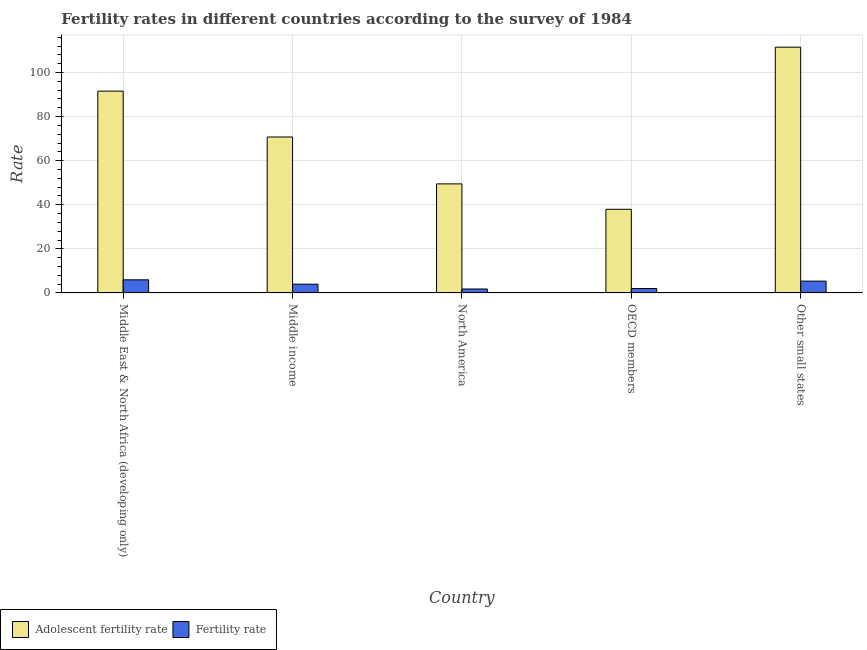How many groups of bars are there?
Make the answer very short. 5. How many bars are there on the 3rd tick from the left?
Provide a succinct answer. 2. How many bars are there on the 2nd tick from the right?
Your response must be concise. 2. What is the label of the 1st group of bars from the left?
Your answer should be very brief. Middle East & North Africa (developing only). What is the fertility rate in Middle income?
Keep it short and to the point. 3.97. Across all countries, what is the maximum fertility rate?
Provide a succinct answer. 5.95. Across all countries, what is the minimum adolescent fertility rate?
Offer a very short reply. 37.95. In which country was the fertility rate maximum?
Ensure brevity in your answer.  Middle East & North Africa (developing only). In which country was the fertility rate minimum?
Offer a very short reply. North America. What is the total fertility rate in the graph?
Your response must be concise. 19.09. What is the difference between the adolescent fertility rate in Middle income and that in Other small states?
Your answer should be very brief. -40.75. What is the difference between the adolescent fertility rate in Middle income and the fertility rate in Middle East & North Africa (developing only)?
Your response must be concise. 64.79. What is the average fertility rate per country?
Offer a very short reply. 3.82. What is the difference between the adolescent fertility rate and fertility rate in OECD members?
Keep it short and to the point. 35.93. In how many countries, is the adolescent fertility rate greater than 88 ?
Your answer should be very brief. 2. What is the ratio of the fertility rate in Middle East & North Africa (developing only) to that in OECD members?
Your answer should be compact. 2.95. Is the fertility rate in Middle East & North Africa (developing only) less than that in Middle income?
Give a very brief answer. No. Is the difference between the fertility rate in Middle income and Other small states greater than the difference between the adolescent fertility rate in Middle income and Other small states?
Provide a short and direct response. Yes. What is the difference between the highest and the second highest adolescent fertility rate?
Make the answer very short. 19.95. What is the difference between the highest and the lowest adolescent fertility rate?
Keep it short and to the point. 73.55. In how many countries, is the adolescent fertility rate greater than the average adolescent fertility rate taken over all countries?
Offer a very short reply. 2. Is the sum of the fertility rate in Middle income and Other small states greater than the maximum adolescent fertility rate across all countries?
Offer a terse response. No. What does the 1st bar from the left in Middle East & North Africa (developing only) represents?
Your answer should be very brief. Adolescent fertility rate. What does the 2nd bar from the right in Other small states represents?
Offer a terse response. Adolescent fertility rate. How many bars are there?
Offer a terse response. 10. Are all the bars in the graph horizontal?
Your response must be concise. No. How many countries are there in the graph?
Offer a very short reply. 5. What is the difference between two consecutive major ticks on the Y-axis?
Offer a terse response. 20. Are the values on the major ticks of Y-axis written in scientific E-notation?
Offer a very short reply. No. Does the graph contain any zero values?
Give a very brief answer. No. Does the graph contain grids?
Provide a succinct answer. Yes. How many legend labels are there?
Make the answer very short. 2. How are the legend labels stacked?
Your answer should be compact. Horizontal. What is the title of the graph?
Your response must be concise. Fertility rates in different countries according to the survey of 1984. What is the label or title of the Y-axis?
Keep it short and to the point. Rate. What is the Rate of Adolescent fertility rate in Middle East & North Africa (developing only)?
Offer a terse response. 91.55. What is the Rate in Fertility rate in Middle East & North Africa (developing only)?
Offer a terse response. 5.95. What is the Rate of Adolescent fertility rate in Middle income?
Offer a very short reply. 70.74. What is the Rate in Fertility rate in Middle income?
Your answer should be very brief. 3.97. What is the Rate in Adolescent fertility rate in North America?
Give a very brief answer. 49.47. What is the Rate in Fertility rate in North America?
Give a very brief answer. 1.79. What is the Rate of Adolescent fertility rate in OECD members?
Your response must be concise. 37.95. What is the Rate of Fertility rate in OECD members?
Keep it short and to the point. 2.02. What is the Rate of Adolescent fertility rate in Other small states?
Provide a short and direct response. 111.5. What is the Rate of Fertility rate in Other small states?
Your answer should be compact. 5.36. Across all countries, what is the maximum Rate of Adolescent fertility rate?
Provide a short and direct response. 111.5. Across all countries, what is the maximum Rate of Fertility rate?
Your answer should be very brief. 5.95. Across all countries, what is the minimum Rate of Adolescent fertility rate?
Ensure brevity in your answer.  37.95. Across all countries, what is the minimum Rate of Fertility rate?
Your answer should be very brief. 1.79. What is the total Rate in Adolescent fertility rate in the graph?
Give a very brief answer. 361.21. What is the total Rate in Fertility rate in the graph?
Make the answer very short. 19.09. What is the difference between the Rate in Adolescent fertility rate in Middle East & North Africa (developing only) and that in Middle income?
Your response must be concise. 20.8. What is the difference between the Rate in Fertility rate in Middle East & North Africa (developing only) and that in Middle income?
Ensure brevity in your answer.  1.98. What is the difference between the Rate in Adolescent fertility rate in Middle East & North Africa (developing only) and that in North America?
Provide a succinct answer. 42.07. What is the difference between the Rate of Fertility rate in Middle East & North Africa (developing only) and that in North America?
Your answer should be compact. 4.16. What is the difference between the Rate of Adolescent fertility rate in Middle East & North Africa (developing only) and that in OECD members?
Give a very brief answer. 53.6. What is the difference between the Rate in Fertility rate in Middle East & North Africa (developing only) and that in OECD members?
Provide a short and direct response. 3.93. What is the difference between the Rate of Adolescent fertility rate in Middle East & North Africa (developing only) and that in Other small states?
Provide a short and direct response. -19.95. What is the difference between the Rate in Fertility rate in Middle East & North Africa (developing only) and that in Other small states?
Provide a succinct answer. 0.59. What is the difference between the Rate of Adolescent fertility rate in Middle income and that in North America?
Give a very brief answer. 21.27. What is the difference between the Rate of Fertility rate in Middle income and that in North America?
Make the answer very short. 2.18. What is the difference between the Rate in Adolescent fertility rate in Middle income and that in OECD members?
Give a very brief answer. 32.79. What is the difference between the Rate of Fertility rate in Middle income and that in OECD members?
Keep it short and to the point. 1.95. What is the difference between the Rate of Adolescent fertility rate in Middle income and that in Other small states?
Your answer should be very brief. -40.75. What is the difference between the Rate of Fertility rate in Middle income and that in Other small states?
Provide a succinct answer. -1.39. What is the difference between the Rate in Adolescent fertility rate in North America and that in OECD members?
Make the answer very short. 11.52. What is the difference between the Rate of Fertility rate in North America and that in OECD members?
Make the answer very short. -0.23. What is the difference between the Rate of Adolescent fertility rate in North America and that in Other small states?
Give a very brief answer. -62.02. What is the difference between the Rate of Fertility rate in North America and that in Other small states?
Your answer should be compact. -3.57. What is the difference between the Rate of Adolescent fertility rate in OECD members and that in Other small states?
Keep it short and to the point. -73.55. What is the difference between the Rate in Fertility rate in OECD members and that in Other small states?
Offer a terse response. -3.34. What is the difference between the Rate in Adolescent fertility rate in Middle East & North Africa (developing only) and the Rate in Fertility rate in Middle income?
Give a very brief answer. 87.57. What is the difference between the Rate in Adolescent fertility rate in Middle East & North Africa (developing only) and the Rate in Fertility rate in North America?
Provide a short and direct response. 89.76. What is the difference between the Rate of Adolescent fertility rate in Middle East & North Africa (developing only) and the Rate of Fertility rate in OECD members?
Make the answer very short. 89.53. What is the difference between the Rate of Adolescent fertility rate in Middle East & North Africa (developing only) and the Rate of Fertility rate in Other small states?
Your answer should be very brief. 86.19. What is the difference between the Rate of Adolescent fertility rate in Middle income and the Rate of Fertility rate in North America?
Give a very brief answer. 68.95. What is the difference between the Rate of Adolescent fertility rate in Middle income and the Rate of Fertility rate in OECD members?
Your answer should be compact. 68.73. What is the difference between the Rate of Adolescent fertility rate in Middle income and the Rate of Fertility rate in Other small states?
Your answer should be very brief. 65.38. What is the difference between the Rate of Adolescent fertility rate in North America and the Rate of Fertility rate in OECD members?
Your answer should be compact. 47.46. What is the difference between the Rate in Adolescent fertility rate in North America and the Rate in Fertility rate in Other small states?
Provide a short and direct response. 44.11. What is the difference between the Rate in Adolescent fertility rate in OECD members and the Rate in Fertility rate in Other small states?
Make the answer very short. 32.59. What is the average Rate of Adolescent fertility rate per country?
Keep it short and to the point. 72.24. What is the average Rate of Fertility rate per country?
Your response must be concise. 3.82. What is the difference between the Rate of Adolescent fertility rate and Rate of Fertility rate in Middle East & North Africa (developing only)?
Your answer should be compact. 85.6. What is the difference between the Rate of Adolescent fertility rate and Rate of Fertility rate in Middle income?
Your answer should be compact. 66.77. What is the difference between the Rate in Adolescent fertility rate and Rate in Fertility rate in North America?
Provide a succinct answer. 47.68. What is the difference between the Rate of Adolescent fertility rate and Rate of Fertility rate in OECD members?
Offer a very short reply. 35.93. What is the difference between the Rate in Adolescent fertility rate and Rate in Fertility rate in Other small states?
Your response must be concise. 106.13. What is the ratio of the Rate in Adolescent fertility rate in Middle East & North Africa (developing only) to that in Middle income?
Offer a very short reply. 1.29. What is the ratio of the Rate of Fertility rate in Middle East & North Africa (developing only) to that in Middle income?
Provide a short and direct response. 1.5. What is the ratio of the Rate of Adolescent fertility rate in Middle East & North Africa (developing only) to that in North America?
Your response must be concise. 1.85. What is the ratio of the Rate in Fertility rate in Middle East & North Africa (developing only) to that in North America?
Offer a terse response. 3.32. What is the ratio of the Rate of Adolescent fertility rate in Middle East & North Africa (developing only) to that in OECD members?
Provide a short and direct response. 2.41. What is the ratio of the Rate in Fertility rate in Middle East & North Africa (developing only) to that in OECD members?
Make the answer very short. 2.95. What is the ratio of the Rate in Adolescent fertility rate in Middle East & North Africa (developing only) to that in Other small states?
Keep it short and to the point. 0.82. What is the ratio of the Rate in Fertility rate in Middle East & North Africa (developing only) to that in Other small states?
Provide a short and direct response. 1.11. What is the ratio of the Rate in Adolescent fertility rate in Middle income to that in North America?
Provide a short and direct response. 1.43. What is the ratio of the Rate of Fertility rate in Middle income to that in North America?
Make the answer very short. 2.22. What is the ratio of the Rate in Adolescent fertility rate in Middle income to that in OECD members?
Provide a short and direct response. 1.86. What is the ratio of the Rate in Fertility rate in Middle income to that in OECD members?
Provide a short and direct response. 1.97. What is the ratio of the Rate of Adolescent fertility rate in Middle income to that in Other small states?
Give a very brief answer. 0.63. What is the ratio of the Rate of Fertility rate in Middle income to that in Other small states?
Keep it short and to the point. 0.74. What is the ratio of the Rate in Adolescent fertility rate in North America to that in OECD members?
Provide a short and direct response. 1.3. What is the ratio of the Rate in Fertility rate in North America to that in OECD members?
Provide a succinct answer. 0.89. What is the ratio of the Rate in Adolescent fertility rate in North America to that in Other small states?
Keep it short and to the point. 0.44. What is the ratio of the Rate of Fertility rate in North America to that in Other small states?
Provide a short and direct response. 0.33. What is the ratio of the Rate in Adolescent fertility rate in OECD members to that in Other small states?
Your answer should be very brief. 0.34. What is the ratio of the Rate in Fertility rate in OECD members to that in Other small states?
Provide a short and direct response. 0.38. What is the difference between the highest and the second highest Rate of Adolescent fertility rate?
Your answer should be compact. 19.95. What is the difference between the highest and the second highest Rate of Fertility rate?
Your answer should be very brief. 0.59. What is the difference between the highest and the lowest Rate of Adolescent fertility rate?
Ensure brevity in your answer.  73.55. What is the difference between the highest and the lowest Rate in Fertility rate?
Your answer should be compact. 4.16. 